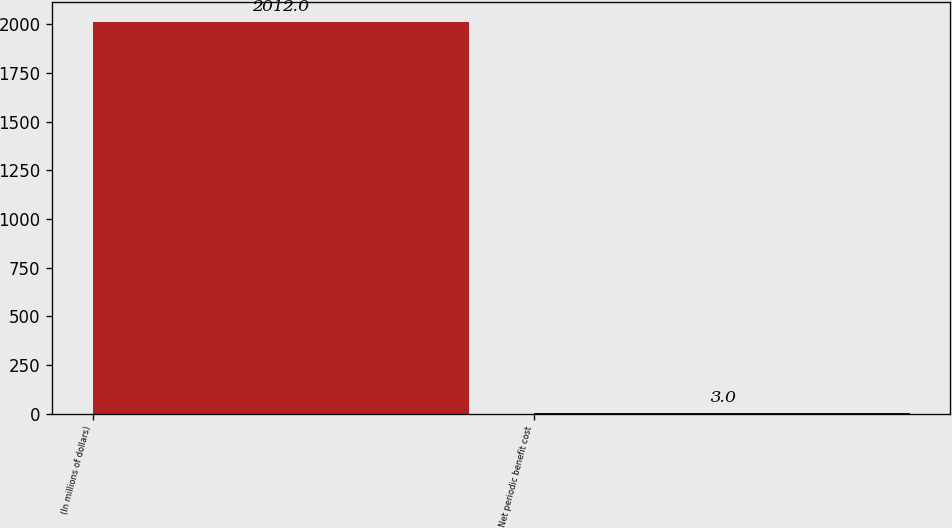Convert chart. <chart><loc_0><loc_0><loc_500><loc_500><bar_chart><fcel>(In millions of dollars)<fcel>Net periodic benefit cost<nl><fcel>2012<fcel>3<nl></chart> 